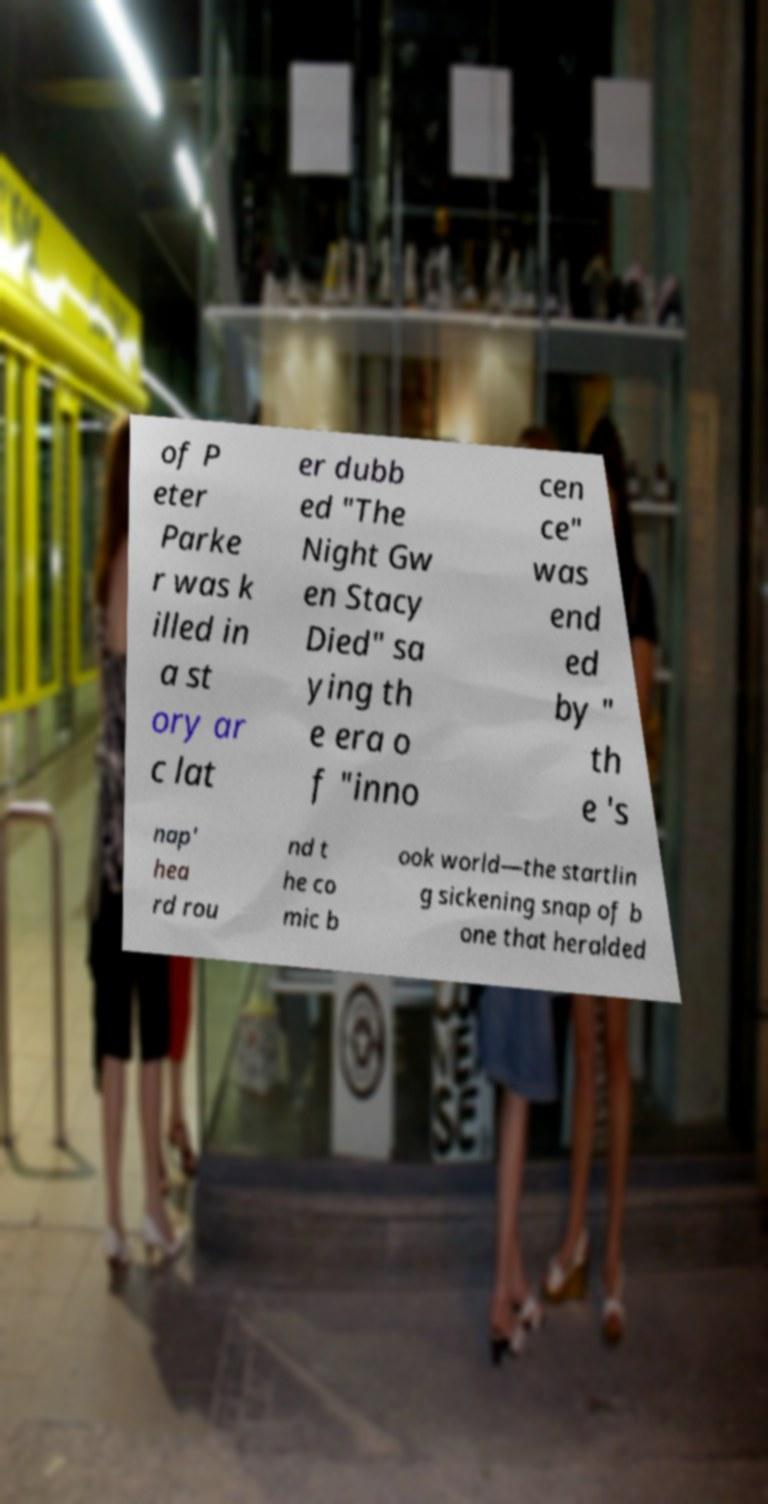What messages or text are displayed in this image? I need them in a readable, typed format. of P eter Parke r was k illed in a st ory ar c lat er dubb ed "The Night Gw en Stacy Died" sa ying th e era o f "inno cen ce" was end ed by " th e 's nap' hea rd rou nd t he co mic b ook world—the startlin g sickening snap of b one that heralded 